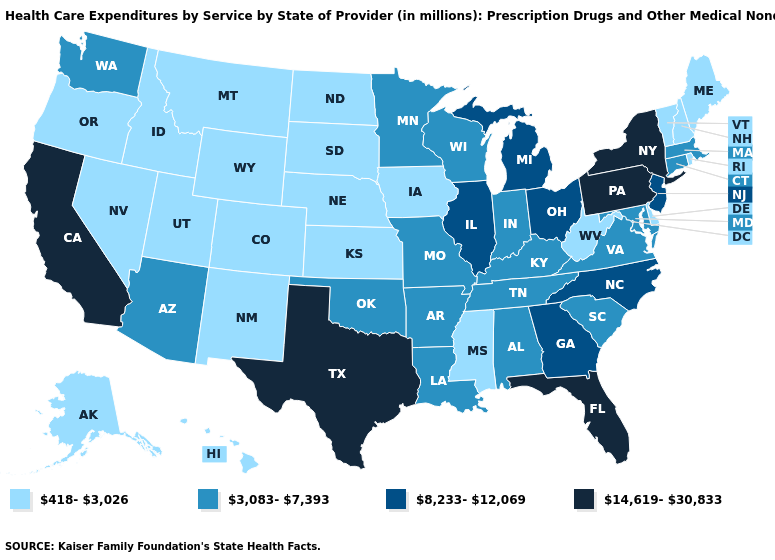Is the legend a continuous bar?
Be succinct. No. Does Mississippi have a lower value than South Dakota?
Short answer required. No. What is the value of Mississippi?
Quick response, please. 418-3,026. Is the legend a continuous bar?
Concise answer only. No. Name the states that have a value in the range 3,083-7,393?
Concise answer only. Alabama, Arizona, Arkansas, Connecticut, Indiana, Kentucky, Louisiana, Maryland, Massachusetts, Minnesota, Missouri, Oklahoma, South Carolina, Tennessee, Virginia, Washington, Wisconsin. Which states have the lowest value in the Northeast?
Write a very short answer. Maine, New Hampshire, Rhode Island, Vermont. Which states have the highest value in the USA?
Be succinct. California, Florida, New York, Pennsylvania, Texas. Does Illinois have the highest value in the MidWest?
Give a very brief answer. Yes. What is the highest value in the South ?
Keep it brief. 14,619-30,833. Among the states that border Alabama , does Florida have the lowest value?
Short answer required. No. What is the highest value in states that border Massachusetts?
Concise answer only. 14,619-30,833. Does South Carolina have a higher value than Oregon?
Short answer required. Yes. Name the states that have a value in the range 418-3,026?
Quick response, please. Alaska, Colorado, Delaware, Hawaii, Idaho, Iowa, Kansas, Maine, Mississippi, Montana, Nebraska, Nevada, New Hampshire, New Mexico, North Dakota, Oregon, Rhode Island, South Dakota, Utah, Vermont, West Virginia, Wyoming. Which states have the lowest value in the USA?
Quick response, please. Alaska, Colorado, Delaware, Hawaii, Idaho, Iowa, Kansas, Maine, Mississippi, Montana, Nebraska, Nevada, New Hampshire, New Mexico, North Dakota, Oregon, Rhode Island, South Dakota, Utah, Vermont, West Virginia, Wyoming. Name the states that have a value in the range 3,083-7,393?
Concise answer only. Alabama, Arizona, Arkansas, Connecticut, Indiana, Kentucky, Louisiana, Maryland, Massachusetts, Minnesota, Missouri, Oklahoma, South Carolina, Tennessee, Virginia, Washington, Wisconsin. 